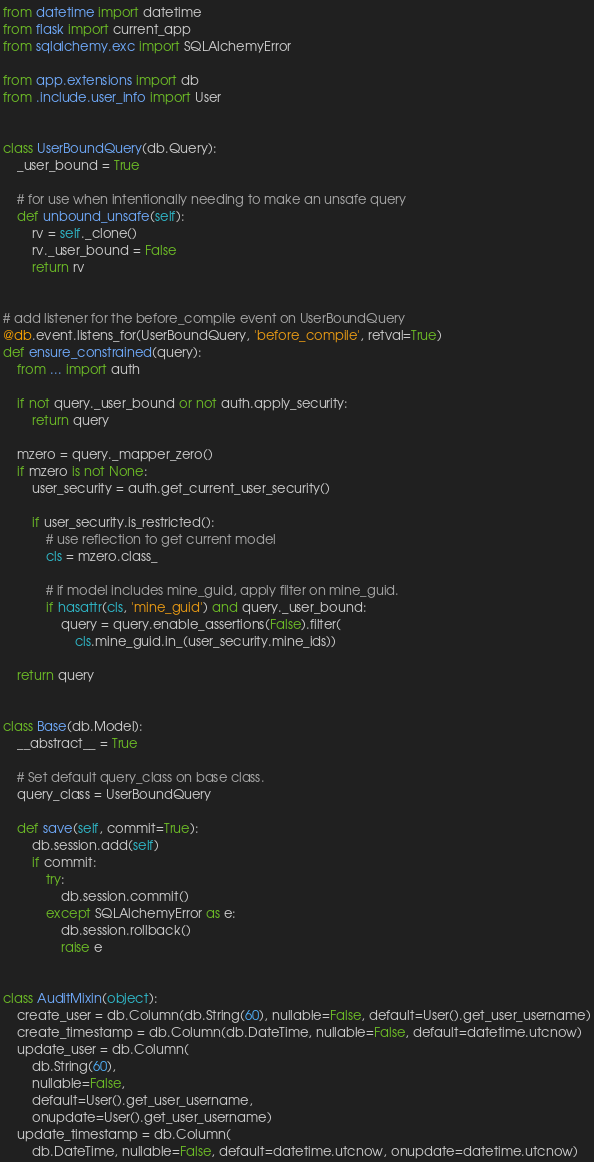Convert code to text. <code><loc_0><loc_0><loc_500><loc_500><_Python_>from datetime import datetime
from flask import current_app
from sqlalchemy.exc import SQLAlchemyError

from app.extensions import db
from .include.user_info import User


class UserBoundQuery(db.Query):
    _user_bound = True

    # for use when intentionally needing to make an unsafe query
    def unbound_unsafe(self):
        rv = self._clone()
        rv._user_bound = False
        return rv


# add listener for the before_compile event on UserBoundQuery
@db.event.listens_for(UserBoundQuery, 'before_compile', retval=True)
def ensure_constrained(query):
    from ... import auth

    if not query._user_bound or not auth.apply_security:
        return query

    mzero = query._mapper_zero()
    if mzero is not None:
        user_security = auth.get_current_user_security()

        if user_security.is_restricted():
            # use reflection to get current model
            cls = mzero.class_

            # if model includes mine_guid, apply filter on mine_guid.
            if hasattr(cls, 'mine_guid') and query._user_bound:
                query = query.enable_assertions(False).filter(
                    cls.mine_guid.in_(user_security.mine_ids))

    return query


class Base(db.Model):
    __abstract__ = True

    # Set default query_class on base class.
    query_class = UserBoundQuery

    def save(self, commit=True):
        db.session.add(self)
        if commit:
            try:
                db.session.commit()
            except SQLAlchemyError as e:
                db.session.rollback()
                raise e


class AuditMixin(object):
    create_user = db.Column(db.String(60), nullable=False, default=User().get_user_username)
    create_timestamp = db.Column(db.DateTime, nullable=False, default=datetime.utcnow)
    update_user = db.Column(
        db.String(60),
        nullable=False,
        default=User().get_user_username,
        onupdate=User().get_user_username)
    update_timestamp = db.Column(
        db.DateTime, nullable=False, default=datetime.utcnow, onupdate=datetime.utcnow)
</code> 